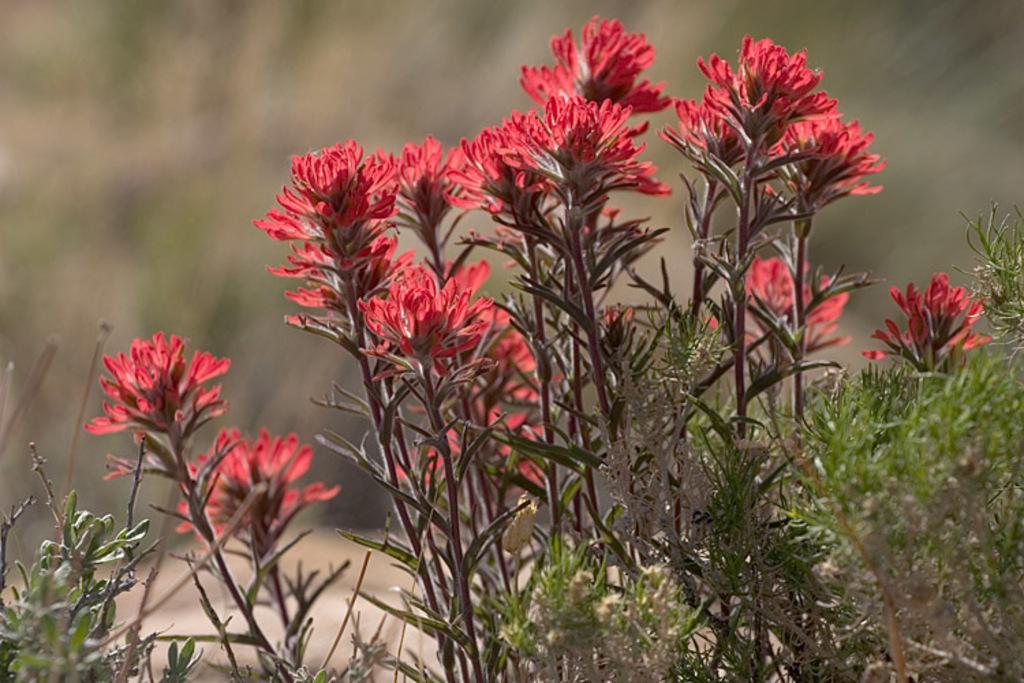Please provide a concise description of this image. In this image we can see red color flower plants. The background is blurry. 